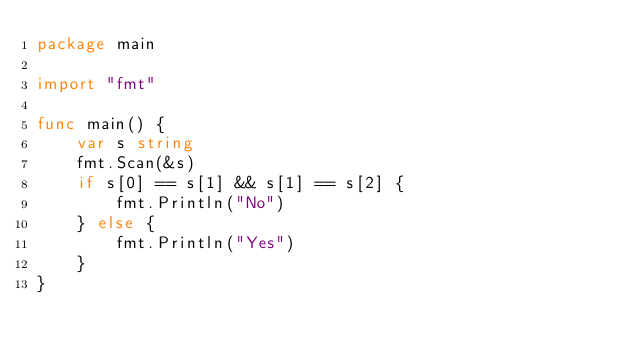Convert code to text. <code><loc_0><loc_0><loc_500><loc_500><_Go_>package main

import "fmt"

func main() {
	var s string
	fmt.Scan(&s)
	if s[0] == s[1] && s[1] == s[2] {
		fmt.Println("No")
	} else {
		fmt.Println("Yes")
	}
}
</code> 